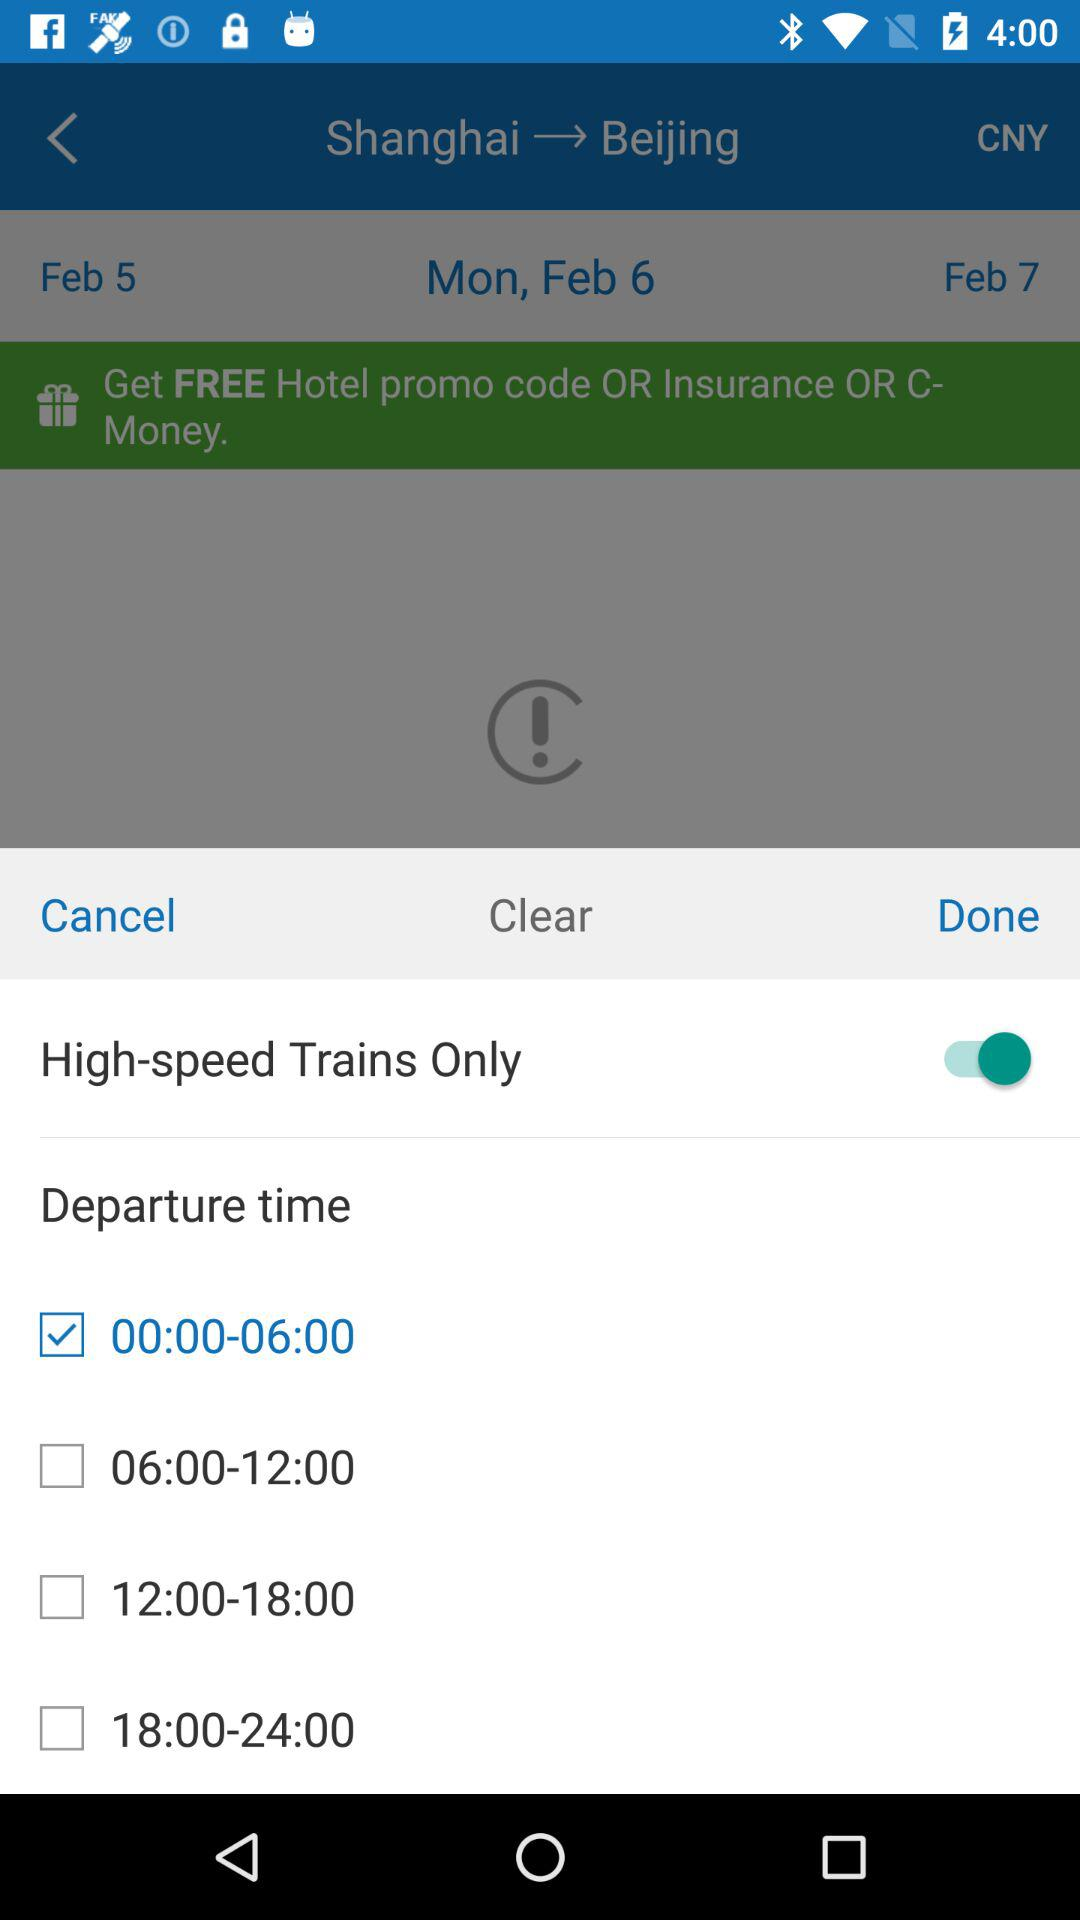How many checkboxes are there for departure time?
Answer the question using a single word or phrase. 4 